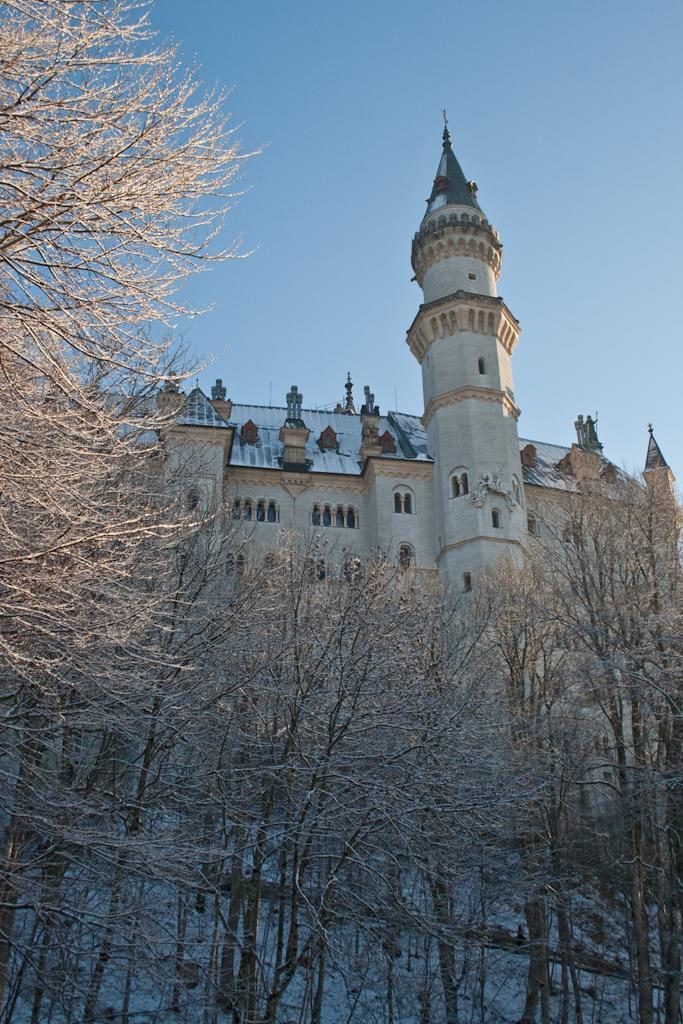How would you summarize this image in a sentence or two? We can see trees, building, snow and sky. 